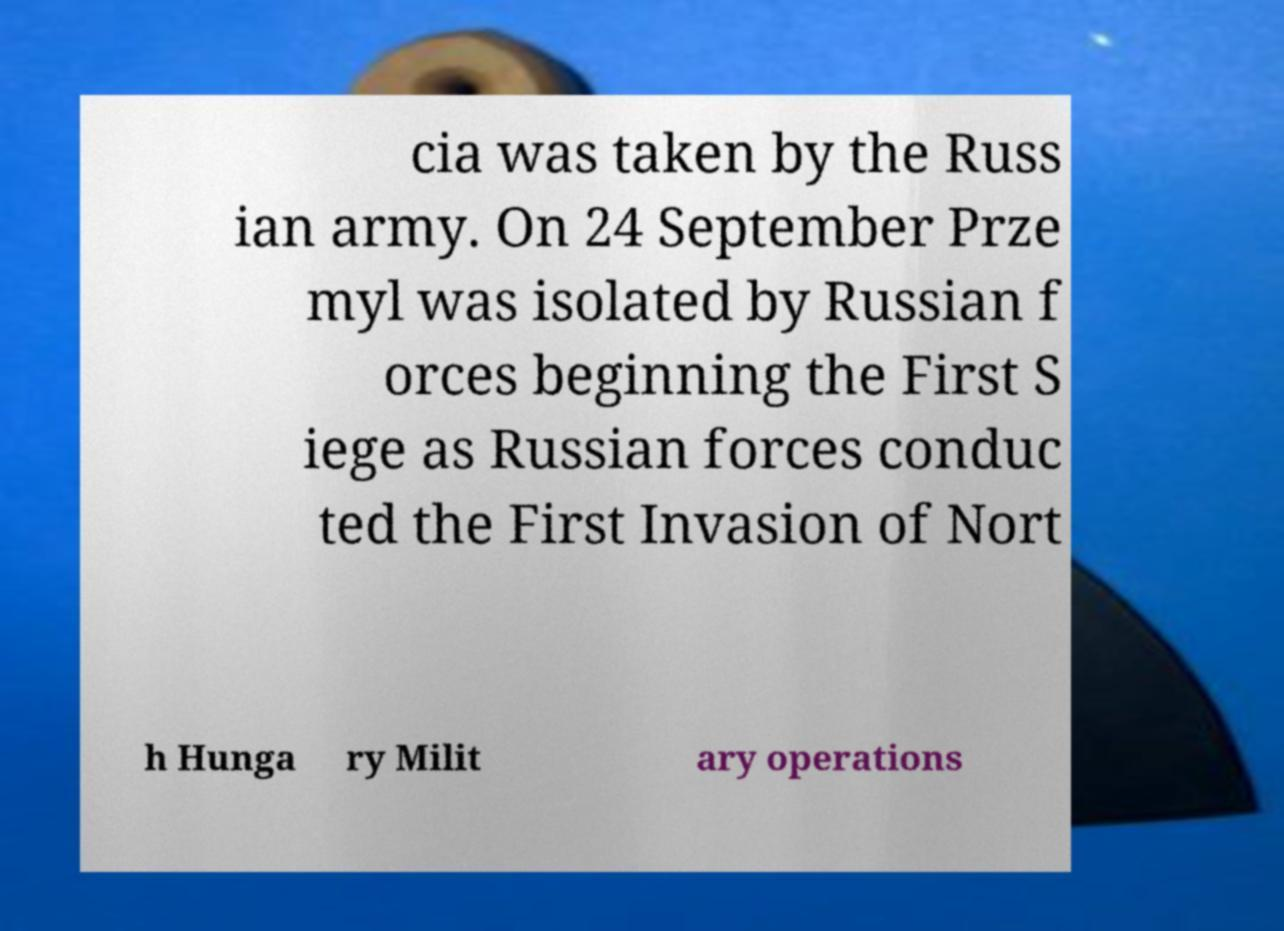Can you accurately transcribe the text from the provided image for me? cia was taken by the Russ ian army. On 24 September Prze myl was isolated by Russian f orces beginning the First S iege as Russian forces conduc ted the First Invasion of Nort h Hunga ry Milit ary operations 